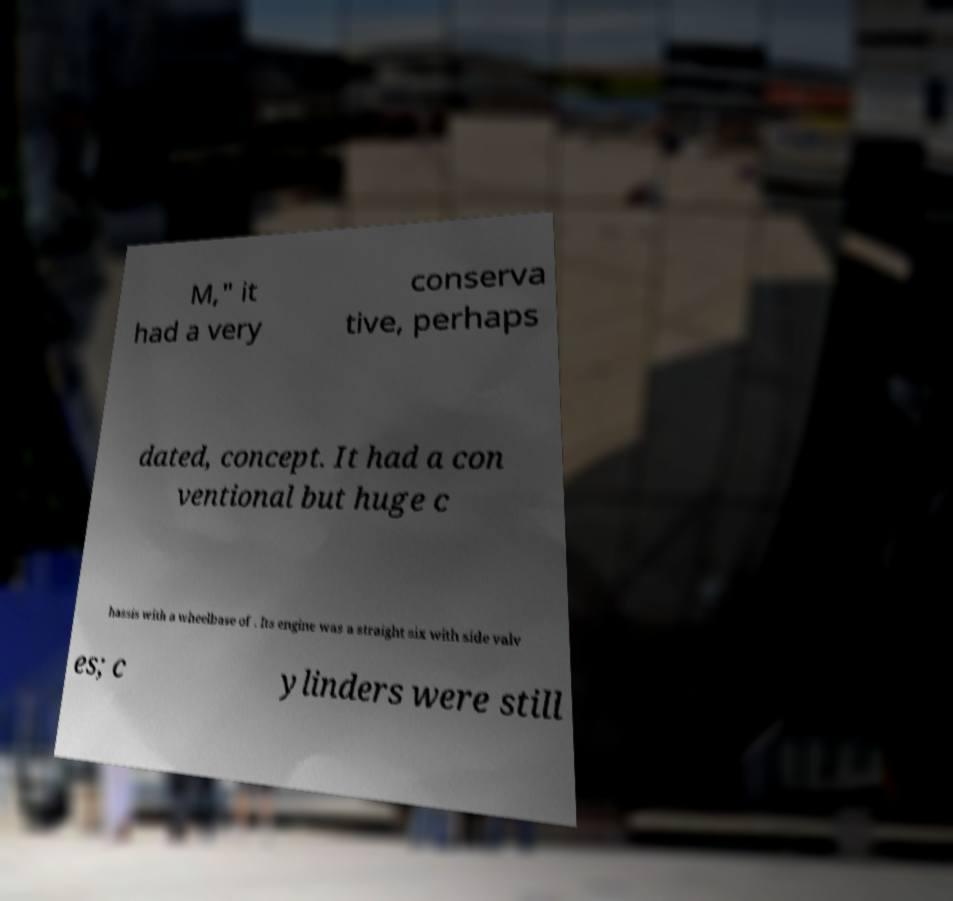Please identify and transcribe the text found in this image. M," it had a very conserva tive, perhaps dated, concept. It had a con ventional but huge c hassis with a wheelbase of . Its engine was a straight six with side valv es; c ylinders were still 